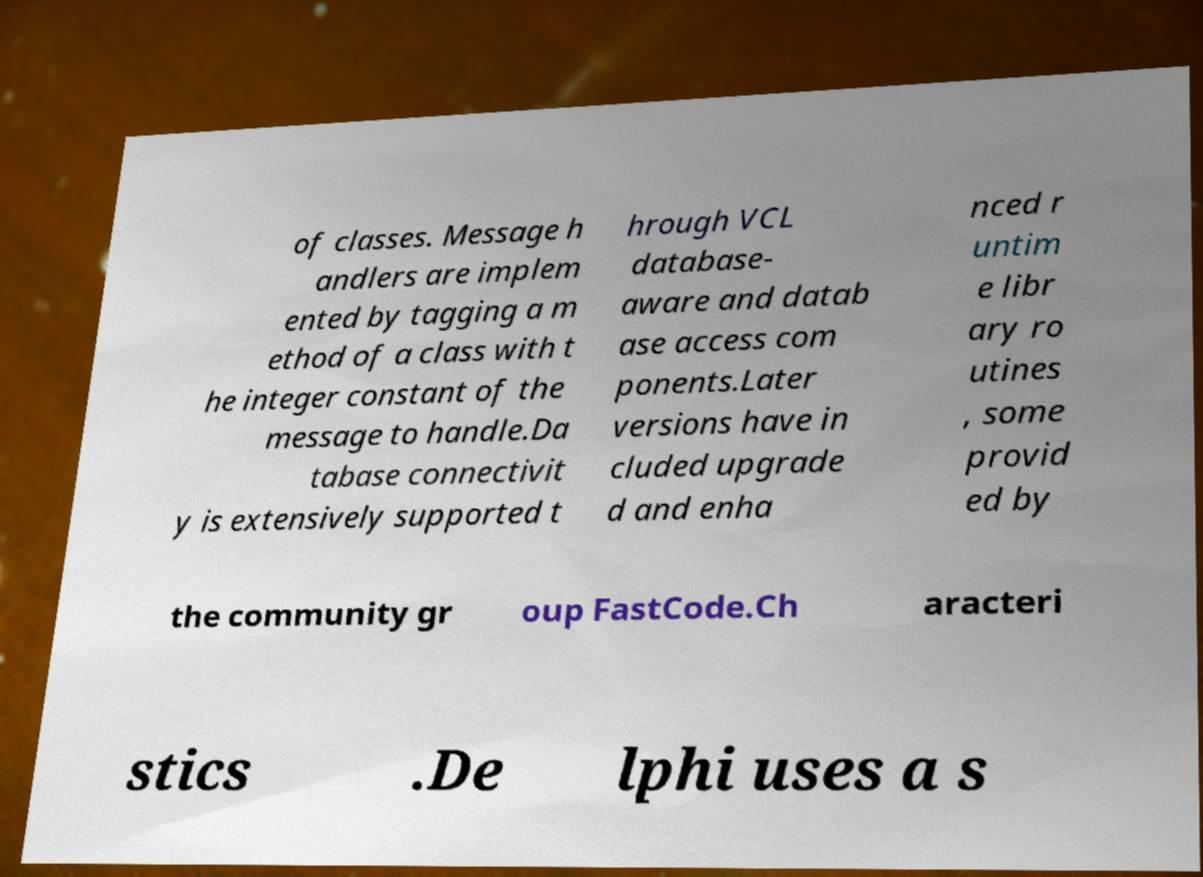For documentation purposes, I need the text within this image transcribed. Could you provide that? of classes. Message h andlers are implem ented by tagging a m ethod of a class with t he integer constant of the message to handle.Da tabase connectivit y is extensively supported t hrough VCL database- aware and datab ase access com ponents.Later versions have in cluded upgrade d and enha nced r untim e libr ary ro utines , some provid ed by the community gr oup FastCode.Ch aracteri stics .De lphi uses a s 